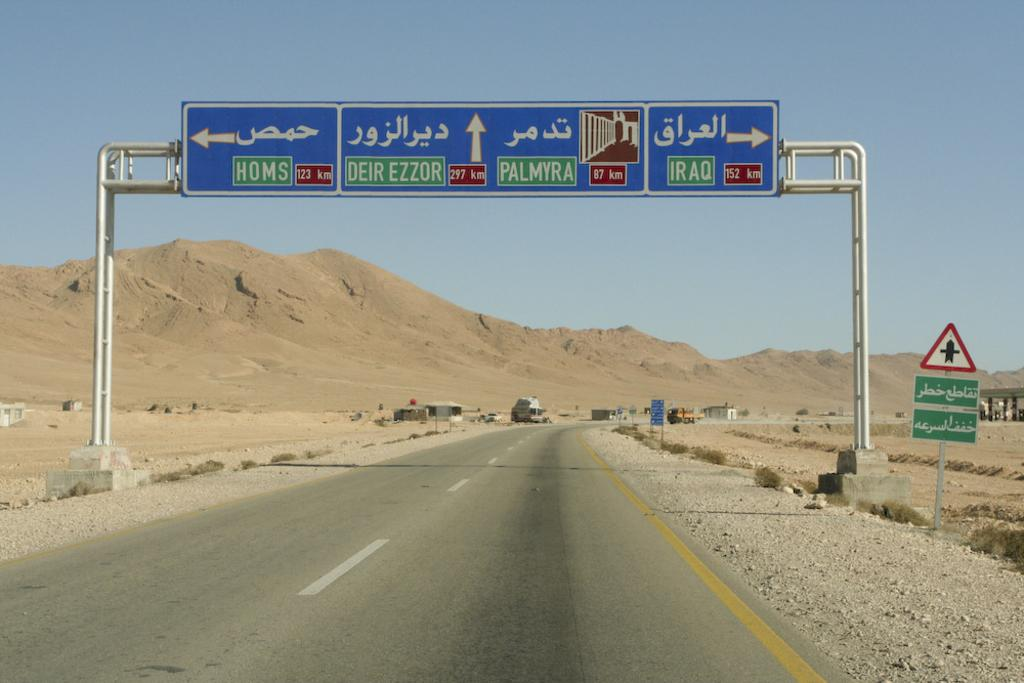<image>
Relay a brief, clear account of the picture shown. a deir label that is above the street 